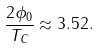Convert formula to latex. <formula><loc_0><loc_0><loc_500><loc_500>\frac { 2 \phi _ { 0 } } { T _ { C } } \approx 3 . 5 2 .</formula> 